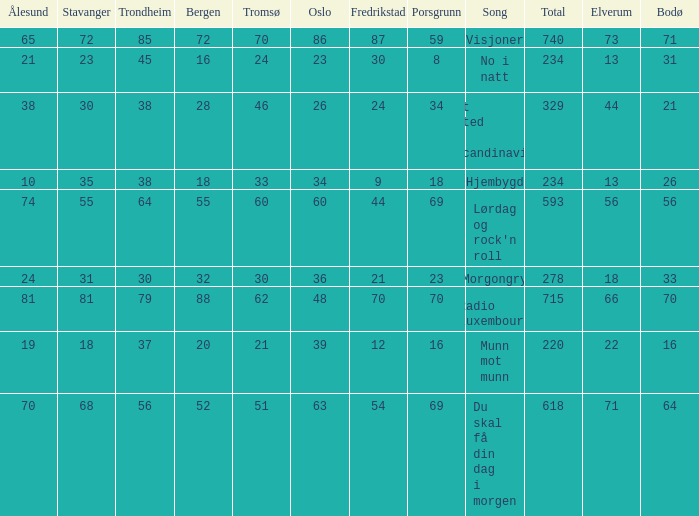What was the total for radio luxembourg? 715.0. 